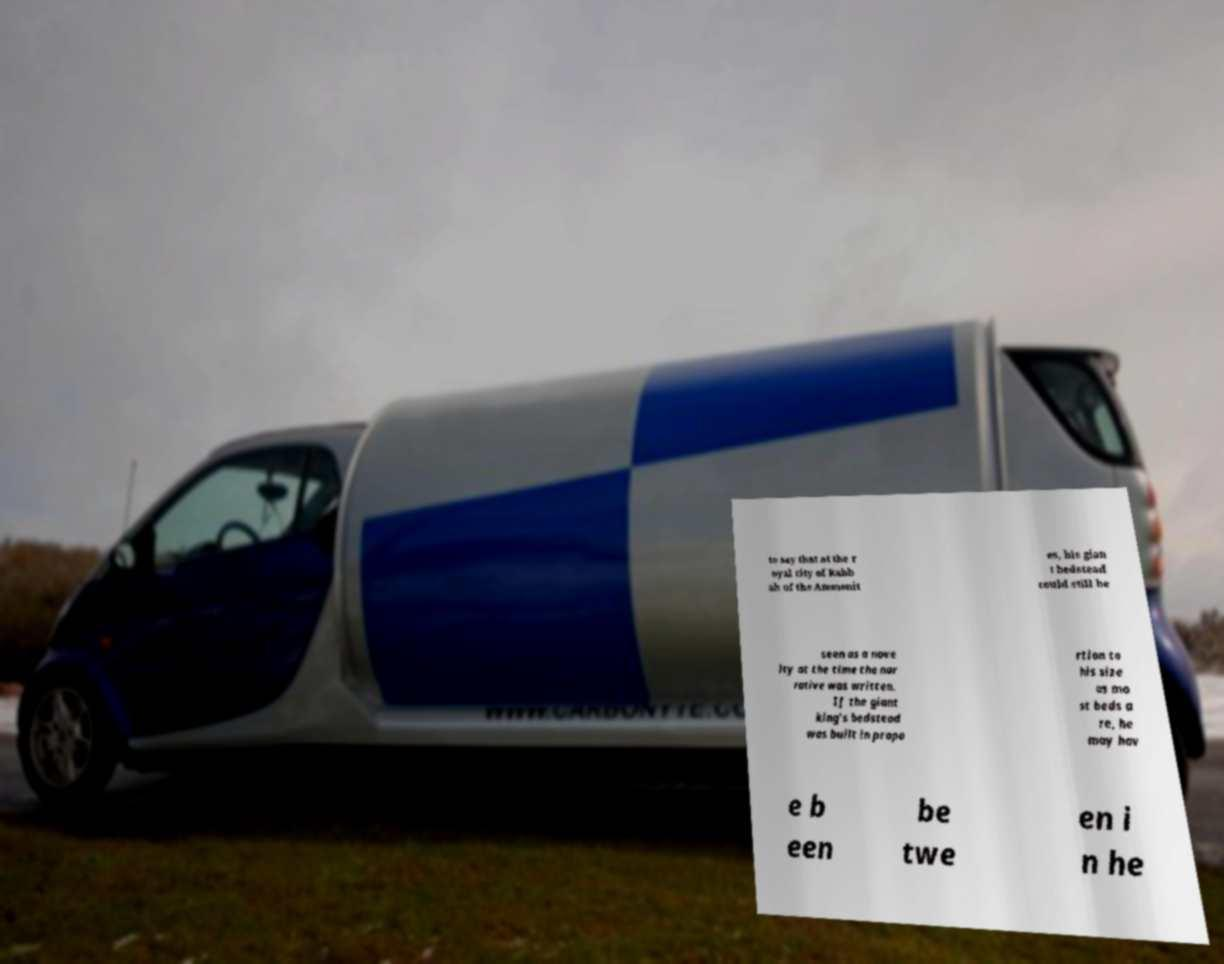What messages or text are displayed in this image? I need them in a readable, typed format. to say that at the r oyal city of Rabb ah of the Ammonit es, his gian t bedstead could still be seen as a nove lty at the time the nar rative was written. If the giant king's bedstead was built in propo rtion to his size as mo st beds a re, he may hav e b een be twe en i n he 